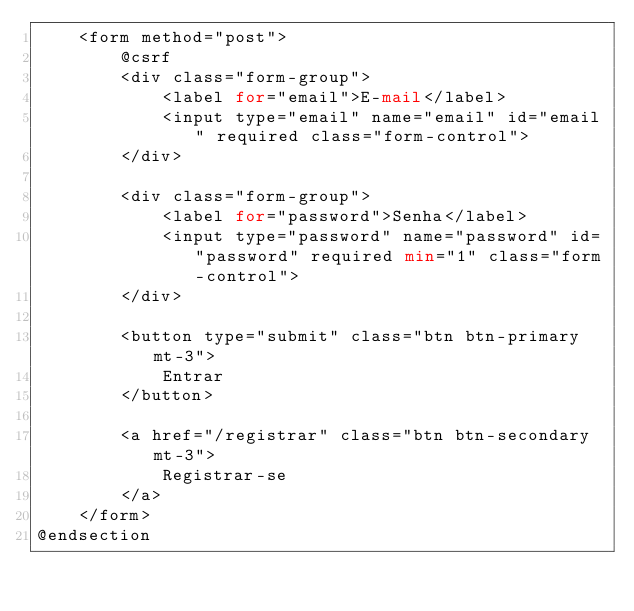<code> <loc_0><loc_0><loc_500><loc_500><_PHP_>    <form method="post">
        @csrf
        <div class="form-group">
            <label for="email">E-mail</label>
            <input type="email" name="email" id="email" required class="form-control">
        </div>

        <div class="form-group">
            <label for="password">Senha</label>
            <input type="password" name="password" id="password" required min="1" class="form-control">
        </div>

        <button type="submit" class="btn btn-primary mt-3">
            Entrar
        </button>

        <a href="/registrar" class="btn btn-secondary mt-3">
            Registrar-se
        </a>
    </form>
@endsection
</code> 